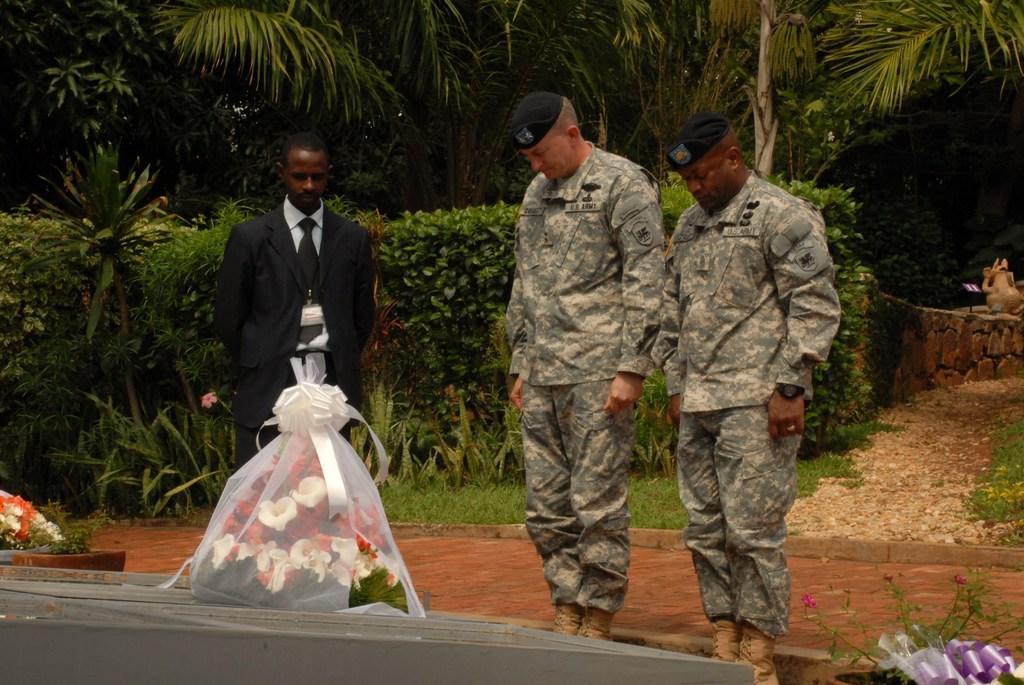Could you give a brief overview of what you see in this image? In this image I can see there are there are three people standing at the bottom left side I can see flowers and at the back side there are many plants and trees. 